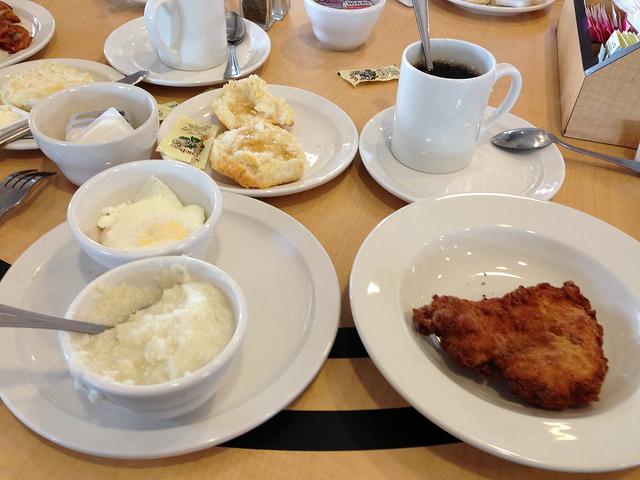What does the mug on the right of the photo say?
Write a very short answer. Nothing. What is the vegetable in the bowl?
Concise answer only. Potato. Is this lunch or dinner?
Quick response, please. Lunch. Is there butter anywhere?
Be succinct. Yes. Is there soy sauce on the table?
Keep it brief. No. What color is the right saucer?
Write a very short answer. White. What color are the cups?
Give a very brief answer. White. How long did it take to cook those grits correctly?
Be succinct. 10 minutes. What utensils are on the plates?
Be succinct. Spoons. What is silver on the plate?
Be succinct. Spoon. What pattern is on the tablecloth?
Short answer required. Stripes. 